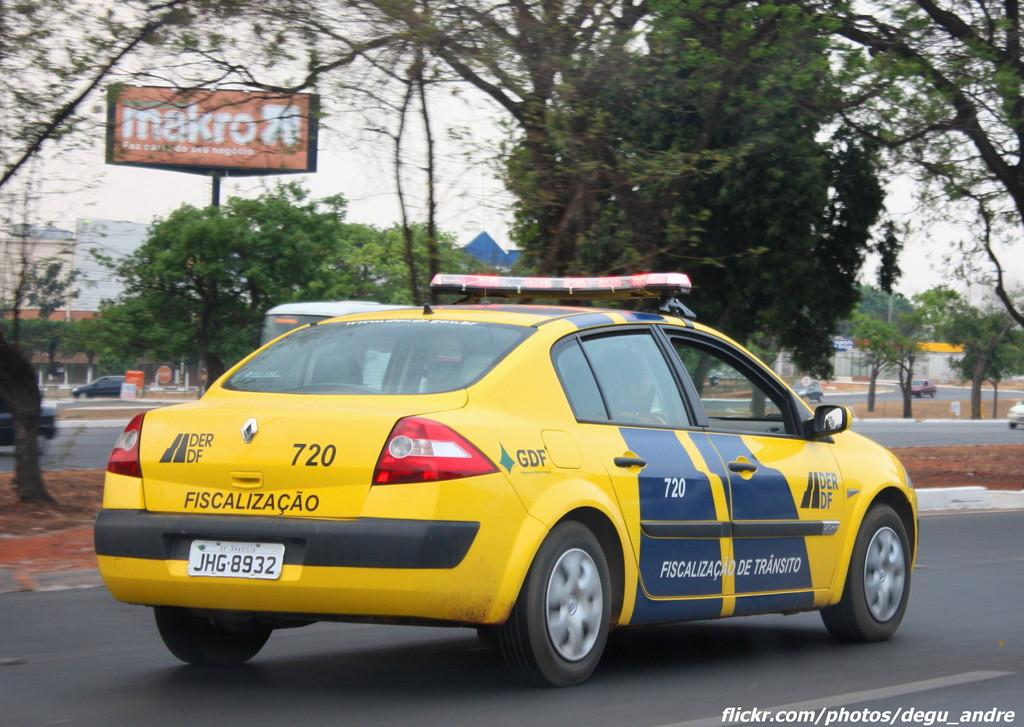<image>
Relay a brief, clear account of the picture shown. a cab with the number 720 on the back 